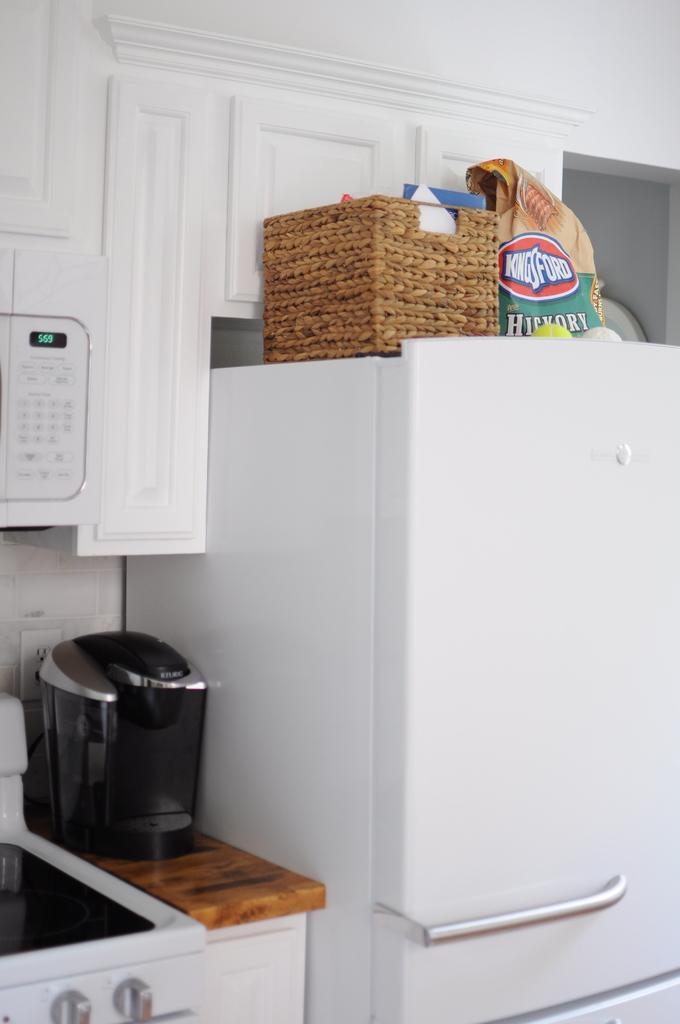<image>
Describe the image concisely. A bag of Kingsford Hickory charcoal sitting on top of a refrigerator 